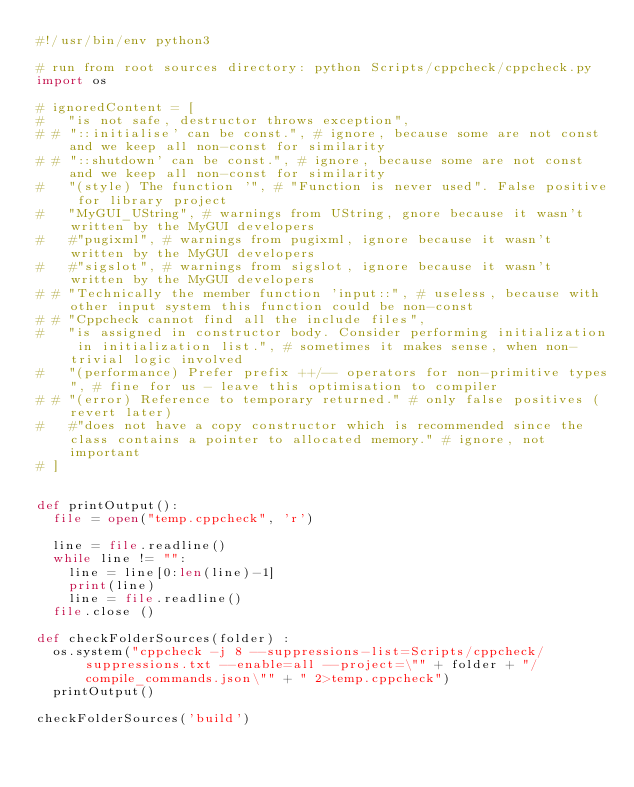Convert code to text. <code><loc_0><loc_0><loc_500><loc_500><_Python_>#!/usr/bin/env python3

# run from root sources directory: python Scripts/cppcheck/cppcheck.py
import os

# ignoredContent = [
# 	"is not safe, destructor throws exception",
# #	"::initialise' can be const.", # ignore, because some are not const and we keep all non-const for similarity
# #	"::shutdown' can be const.", # ignore, because some are not const and we keep all non-const for similarity
# 	"(style) The function '", # "Function is never used". False positive for library project
# 	"MyGUI_UString", # warnings from UString, gnore because it wasn't written by the MyGUI developers
# 	#"pugixml", # warnings from pugixml, ignore because it wasn't written by the MyGUI developers
# 	#"sigslot", # warnings from sigslot, ignore because it wasn't written by the MyGUI developers
# #	"Technically the member function 'input::", # useless, because with other input system this function could be non-const
# #	"Cppcheck cannot find all the include files",
# 	"is assigned in constructor body. Consider performing initialization in initialization list.", # sometimes it makes sense, when non-trivial logic involved
# 	"(performance) Prefer prefix ++/-- operators for non-primitive types", # fine for us - leave this optimisation to compiler
# #	"(error) Reference to temporary returned." # only false positives (revert later)
# 	#"does not have a copy constructor which is recommended since the class contains a pointer to allocated memory." # ignore, not important
# ]


def printOutput():
	file = open("temp.cppcheck", 'r')

	line = file.readline()
	while line != "":
		line = line[0:len(line)-1]
		print(line)
		line = file.readline()
	file.close ()

def checkFolderSources(folder) :
	os.system("cppcheck -j 8 --suppressions-list=Scripts/cppcheck/suppressions.txt --enable=all --project=\"" + folder + "/compile_commands.json\"" + " 2>temp.cppcheck")
	printOutput()

checkFolderSources('build')
</code> 